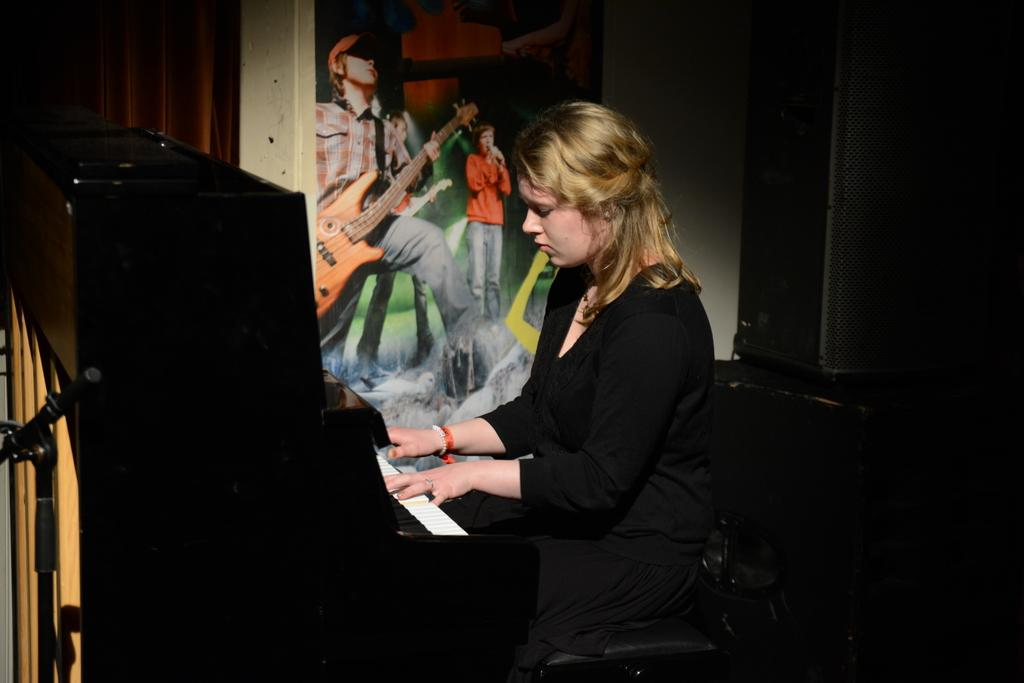What is the lady in the image doing? The lady is sitting in the center of the image and playing a piano. What can be seen on the wall in the background? There is a poster on the wall in the background. What other object is visible in the background? There is a sound box visible in the background. Can you see any beans growing near the lady in the image? There are no beans visible in the image. Is there a lake in the background of the image? There is no lake present in the image. 